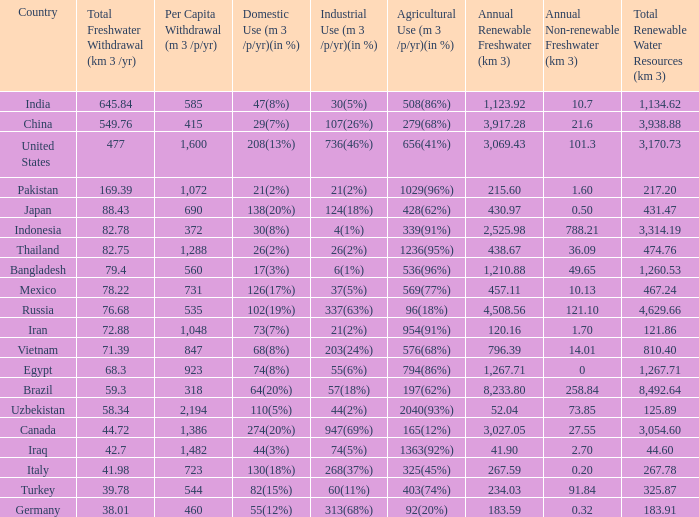What is the highest Per Capita Withdrawal (m 3 /p/yr), when Agricultural Use (m 3 /p/yr)(in %) is 1363(92%), and when Total Freshwater Withdrawal (km 3 /yr) is less than 42.7? None. 